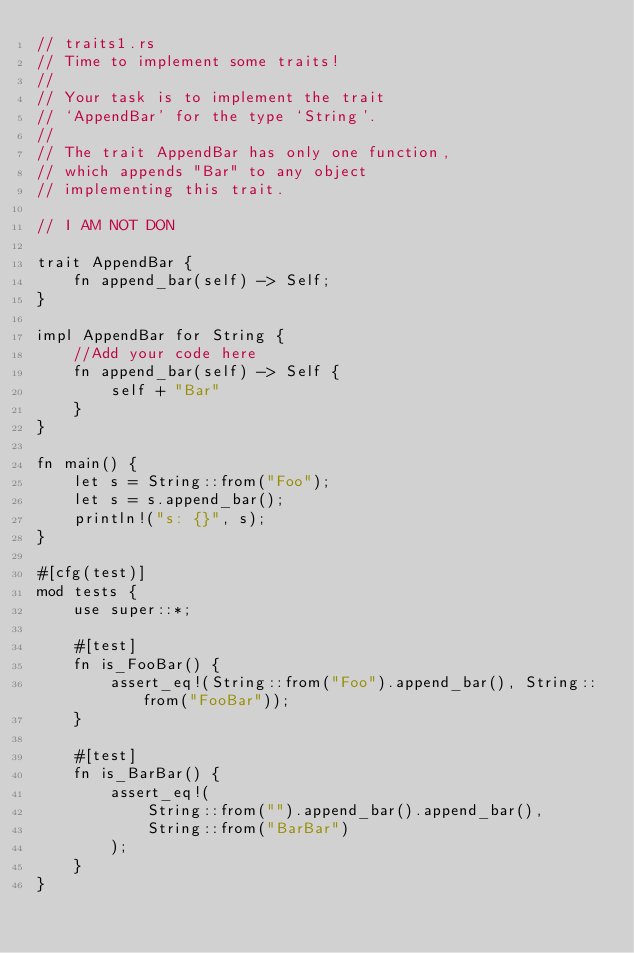Convert code to text. <code><loc_0><loc_0><loc_500><loc_500><_Rust_>// traits1.rs
// Time to implement some traits!
//
// Your task is to implement the trait
// `AppendBar' for the type `String'.
//
// The trait AppendBar has only one function,
// which appends "Bar" to any object
// implementing this trait.

// I AM NOT DON

trait AppendBar {
    fn append_bar(self) -> Self;
}

impl AppendBar for String {
    //Add your code here
    fn append_bar(self) -> Self {
        self + "Bar"
    }
}

fn main() {
    let s = String::from("Foo");
    let s = s.append_bar();
    println!("s: {}", s);
}

#[cfg(test)]
mod tests {
    use super::*;

    #[test]
    fn is_FooBar() {
        assert_eq!(String::from("Foo").append_bar(), String::from("FooBar"));
    }

    #[test]
    fn is_BarBar() {
        assert_eq!(
            String::from("").append_bar().append_bar(),
            String::from("BarBar")
        );
    }
}
</code> 